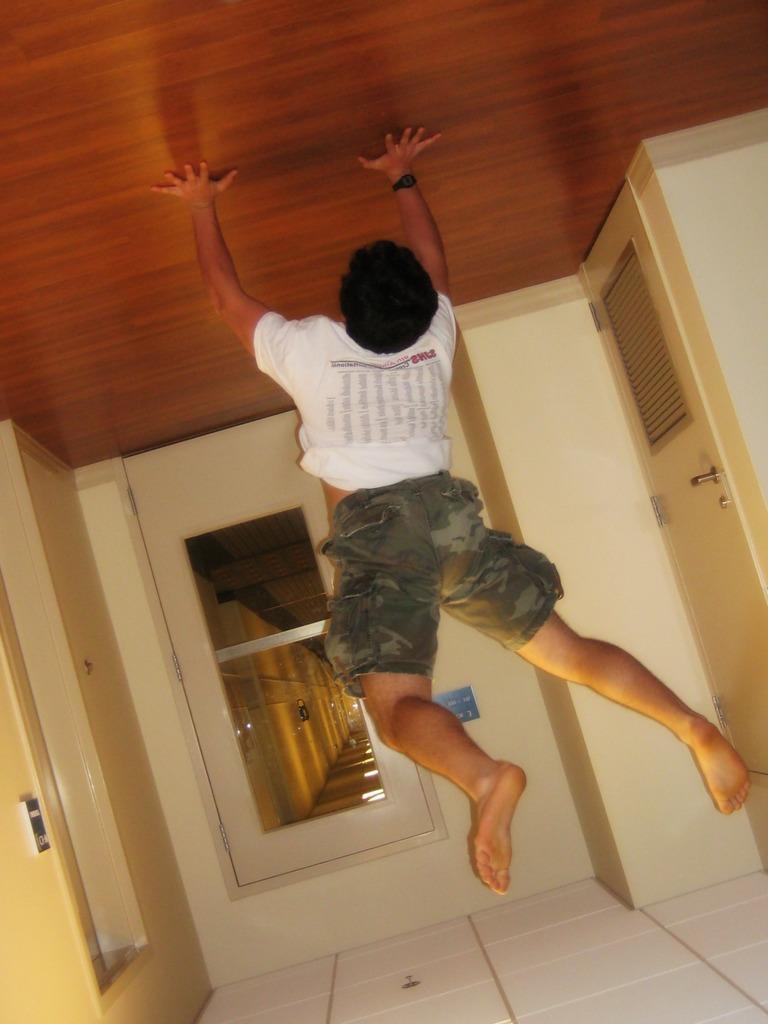In one or two sentences, can you explain what this image depicts? In this image we can see a person. There are few doors in the image. There is an object on the wall at the left side of the image. 